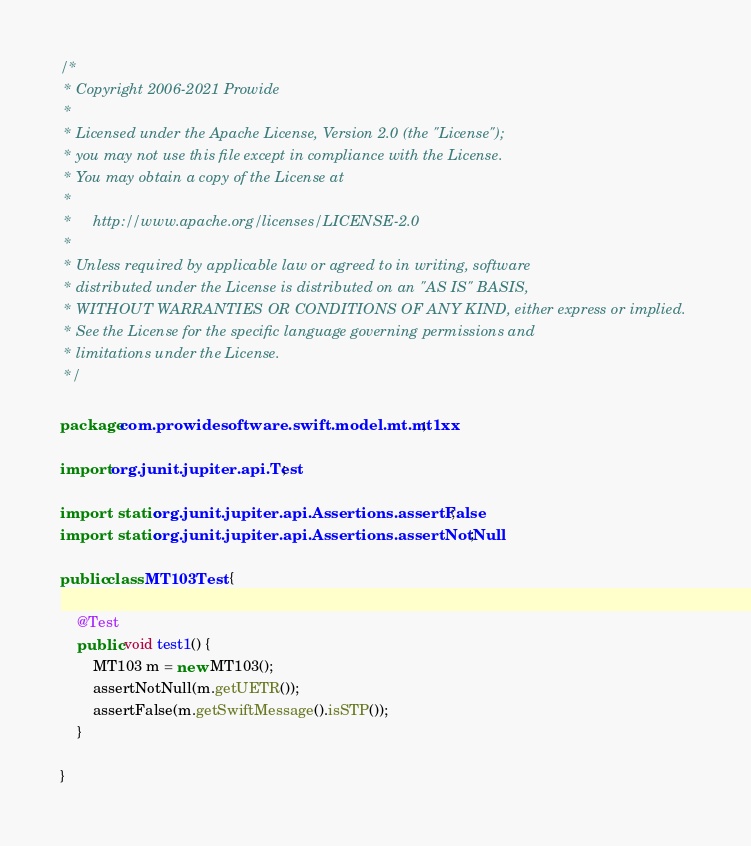<code> <loc_0><loc_0><loc_500><loc_500><_Java_>/*
 * Copyright 2006-2021 Prowide
 *
 * Licensed under the Apache License, Version 2.0 (the "License");
 * you may not use this file except in compliance with the License.
 * You may obtain a copy of the License at
 *
 *     http://www.apache.org/licenses/LICENSE-2.0
 *
 * Unless required by applicable law or agreed to in writing, software
 * distributed under the License is distributed on an "AS IS" BASIS,
 * WITHOUT WARRANTIES OR CONDITIONS OF ANY KIND, either express or implied.
 * See the License for the specific language governing permissions and
 * limitations under the License.
 */

package com.prowidesoftware.swift.model.mt.mt1xx;

import org.junit.jupiter.api.Test;

import static org.junit.jupiter.api.Assertions.assertFalse;
import static org.junit.jupiter.api.Assertions.assertNotNull;

public class MT103Test {

    @Test
    public void test1() {
        MT103 m = new MT103();
        assertNotNull(m.getUETR());
        assertFalse(m.getSwiftMessage().isSTP());
    }

}
</code> 